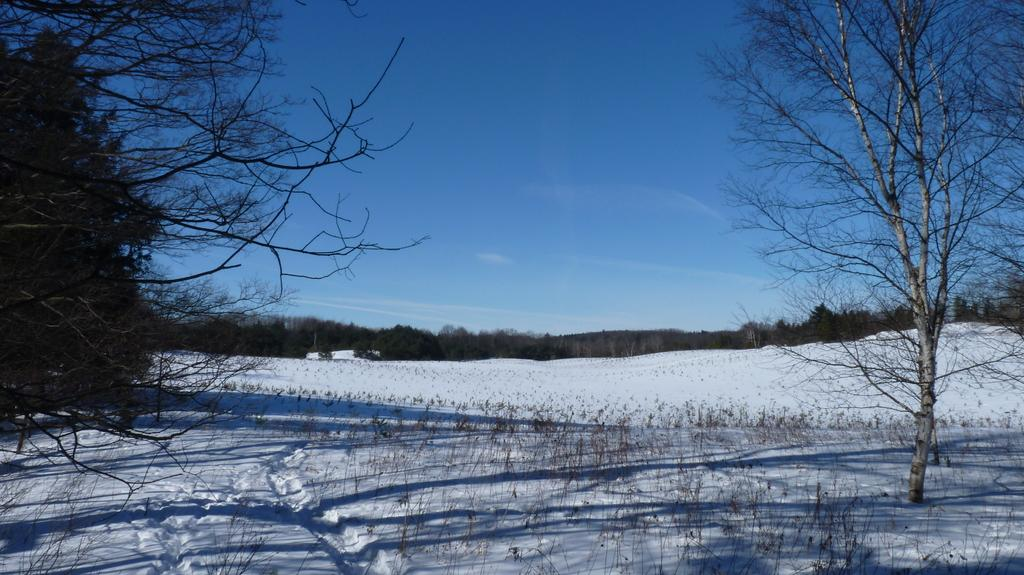What type of vegetation is visible at the bottom of the image? There are bare plants and trees at the bottom of the image. What is the surface on which the plants and trees are situated? The plants and trees are on snow. What can be seen in the background of the image? There are trees and clouds in the sky in the background of the image. Can you see the writer working on their manuscript in the image? There is no writer or manuscript present in the image; it features bare plants and trees on snow with a background of trees and clouds in the sky. How many ladybugs are visible on the plants in the image? There are no ladybugs present in the image; it only features plants and trees on snow with a background of trees and clouds in the sky. 